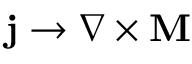<formula> <loc_0><loc_0><loc_500><loc_500>j \rightarrow \nabla \times M</formula> 